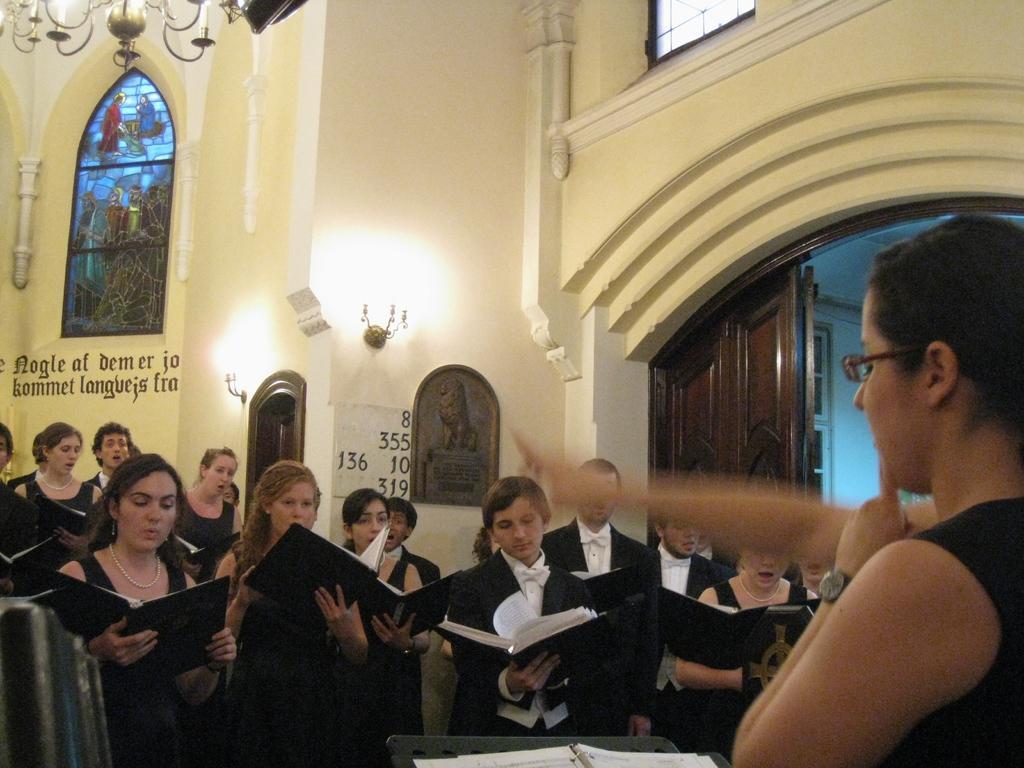In one or two sentences, can you explain what this image depicts? In this image I can see there are group of persons holding books and in front of them I can see a woman wearing a watch visible on the right side,at the top I can see the building wall , on the wall I can see windows ,text and door and painting and chandelier at the top. 